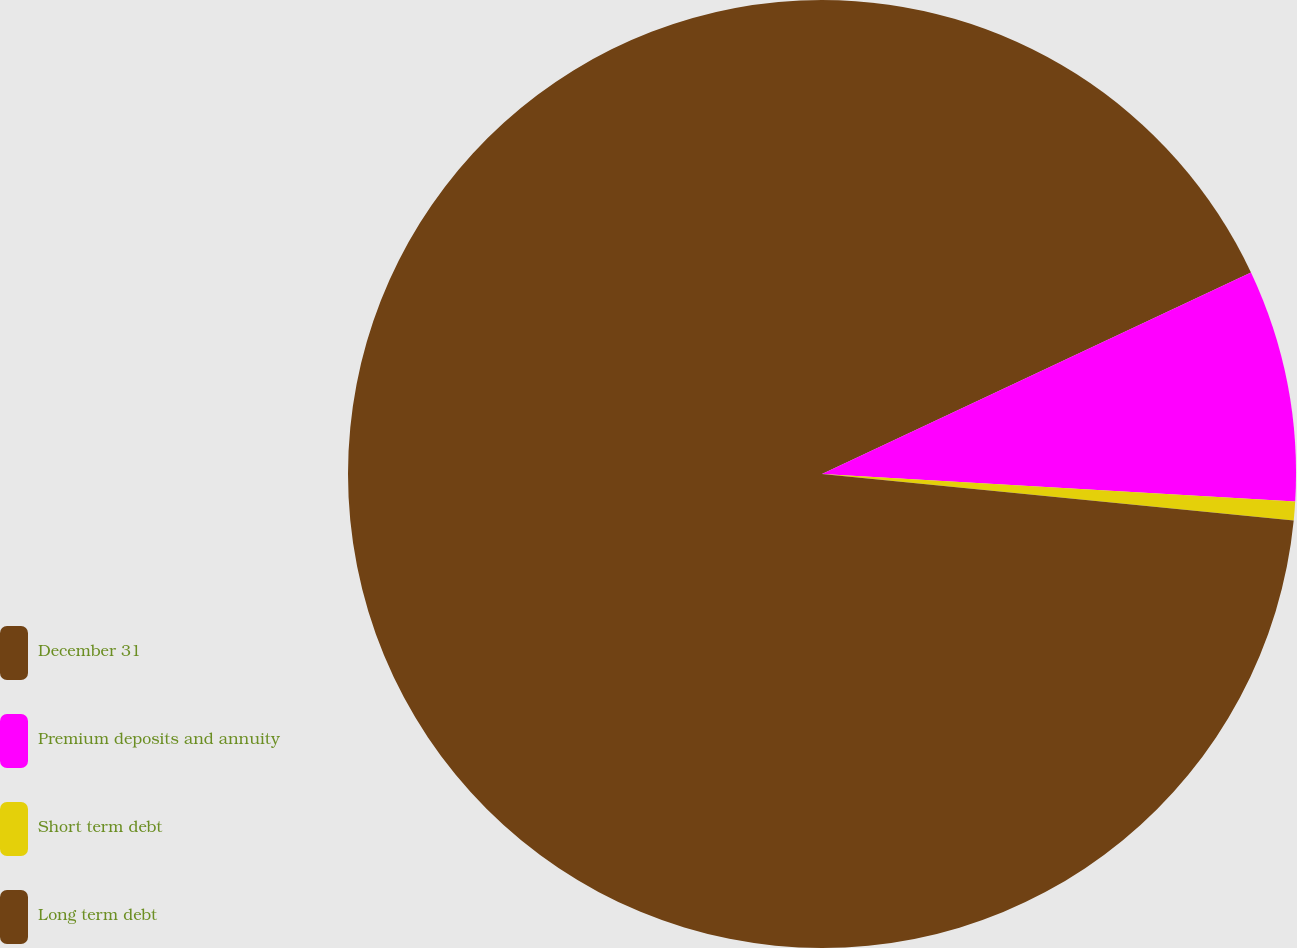<chart> <loc_0><loc_0><loc_500><loc_500><pie_chart><fcel>December 31<fcel>Premium deposits and annuity<fcel>Short term debt<fcel>Long term debt<nl><fcel>18.01%<fcel>7.92%<fcel>0.64%<fcel>73.44%<nl></chart> 